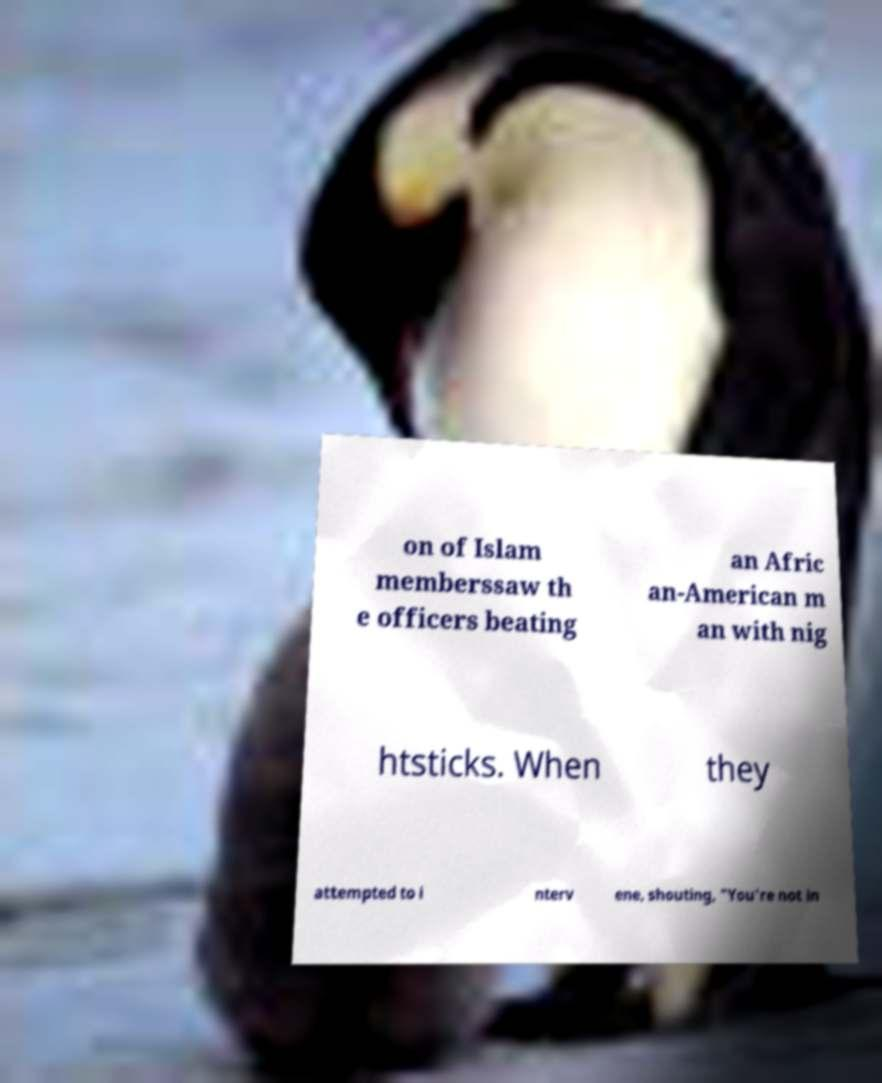Can you accurately transcribe the text from the provided image for me? on of Islam memberssaw th e officers beating an Afric an-American m an with nig htsticks. When they attempted to i nterv ene, shouting, "You're not in 